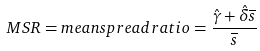<formula> <loc_0><loc_0><loc_500><loc_500>M S R = m e a n s p r e a d r a t i o = \frac { \hat { \gamma } + \hat { \delta } \overline { s } } { \overline { s } }</formula> 